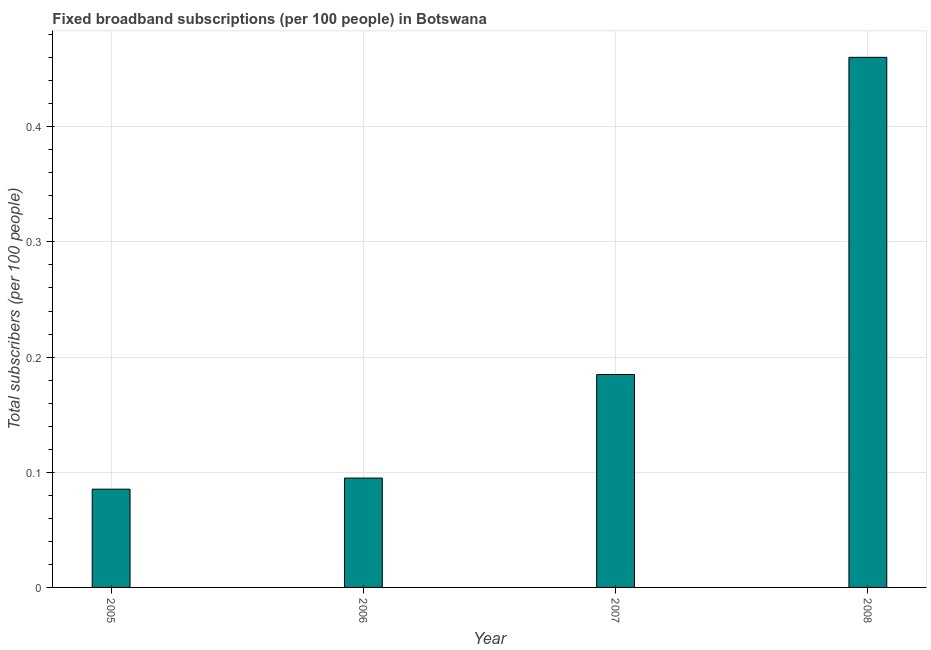Does the graph contain grids?
Your answer should be compact. Yes. What is the title of the graph?
Ensure brevity in your answer.  Fixed broadband subscriptions (per 100 people) in Botswana. What is the label or title of the X-axis?
Your answer should be compact. Year. What is the label or title of the Y-axis?
Make the answer very short. Total subscribers (per 100 people). What is the total number of fixed broadband subscriptions in 2005?
Your response must be concise. 0.09. Across all years, what is the maximum total number of fixed broadband subscriptions?
Provide a short and direct response. 0.46. Across all years, what is the minimum total number of fixed broadband subscriptions?
Give a very brief answer. 0.09. In which year was the total number of fixed broadband subscriptions maximum?
Ensure brevity in your answer.  2008. In which year was the total number of fixed broadband subscriptions minimum?
Your answer should be compact. 2005. What is the sum of the total number of fixed broadband subscriptions?
Provide a short and direct response. 0.83. What is the difference between the total number of fixed broadband subscriptions in 2006 and 2008?
Ensure brevity in your answer.  -0.36. What is the average total number of fixed broadband subscriptions per year?
Your answer should be compact. 0.21. What is the median total number of fixed broadband subscriptions?
Ensure brevity in your answer.  0.14. In how many years, is the total number of fixed broadband subscriptions greater than 0.34 ?
Keep it short and to the point. 1. Do a majority of the years between 2006 and 2007 (inclusive) have total number of fixed broadband subscriptions greater than 0.16 ?
Provide a short and direct response. No. What is the ratio of the total number of fixed broadband subscriptions in 2005 to that in 2007?
Ensure brevity in your answer.  0.46. Is the difference between the total number of fixed broadband subscriptions in 2006 and 2008 greater than the difference between any two years?
Your response must be concise. No. What is the difference between the highest and the second highest total number of fixed broadband subscriptions?
Your answer should be compact. 0.28. Is the sum of the total number of fixed broadband subscriptions in 2005 and 2006 greater than the maximum total number of fixed broadband subscriptions across all years?
Make the answer very short. No. What is the difference between the highest and the lowest total number of fixed broadband subscriptions?
Keep it short and to the point. 0.37. In how many years, is the total number of fixed broadband subscriptions greater than the average total number of fixed broadband subscriptions taken over all years?
Offer a terse response. 1. Are all the bars in the graph horizontal?
Provide a short and direct response. No. How many years are there in the graph?
Your answer should be compact. 4. What is the Total subscribers (per 100 people) of 2005?
Give a very brief answer. 0.09. What is the Total subscribers (per 100 people) in 2006?
Give a very brief answer. 0.09. What is the Total subscribers (per 100 people) of 2007?
Your response must be concise. 0.18. What is the Total subscribers (per 100 people) in 2008?
Provide a succinct answer. 0.46. What is the difference between the Total subscribers (per 100 people) in 2005 and 2006?
Your answer should be very brief. -0.01. What is the difference between the Total subscribers (per 100 people) in 2005 and 2007?
Make the answer very short. -0.1. What is the difference between the Total subscribers (per 100 people) in 2005 and 2008?
Give a very brief answer. -0.37. What is the difference between the Total subscribers (per 100 people) in 2006 and 2007?
Make the answer very short. -0.09. What is the difference between the Total subscribers (per 100 people) in 2006 and 2008?
Your response must be concise. -0.37. What is the difference between the Total subscribers (per 100 people) in 2007 and 2008?
Offer a very short reply. -0.28. What is the ratio of the Total subscribers (per 100 people) in 2005 to that in 2006?
Provide a short and direct response. 0.9. What is the ratio of the Total subscribers (per 100 people) in 2005 to that in 2007?
Offer a very short reply. 0.46. What is the ratio of the Total subscribers (per 100 people) in 2005 to that in 2008?
Provide a succinct answer. 0.18. What is the ratio of the Total subscribers (per 100 people) in 2006 to that in 2007?
Provide a succinct answer. 0.51. What is the ratio of the Total subscribers (per 100 people) in 2006 to that in 2008?
Your response must be concise. 0.21. What is the ratio of the Total subscribers (per 100 people) in 2007 to that in 2008?
Your answer should be very brief. 0.4. 